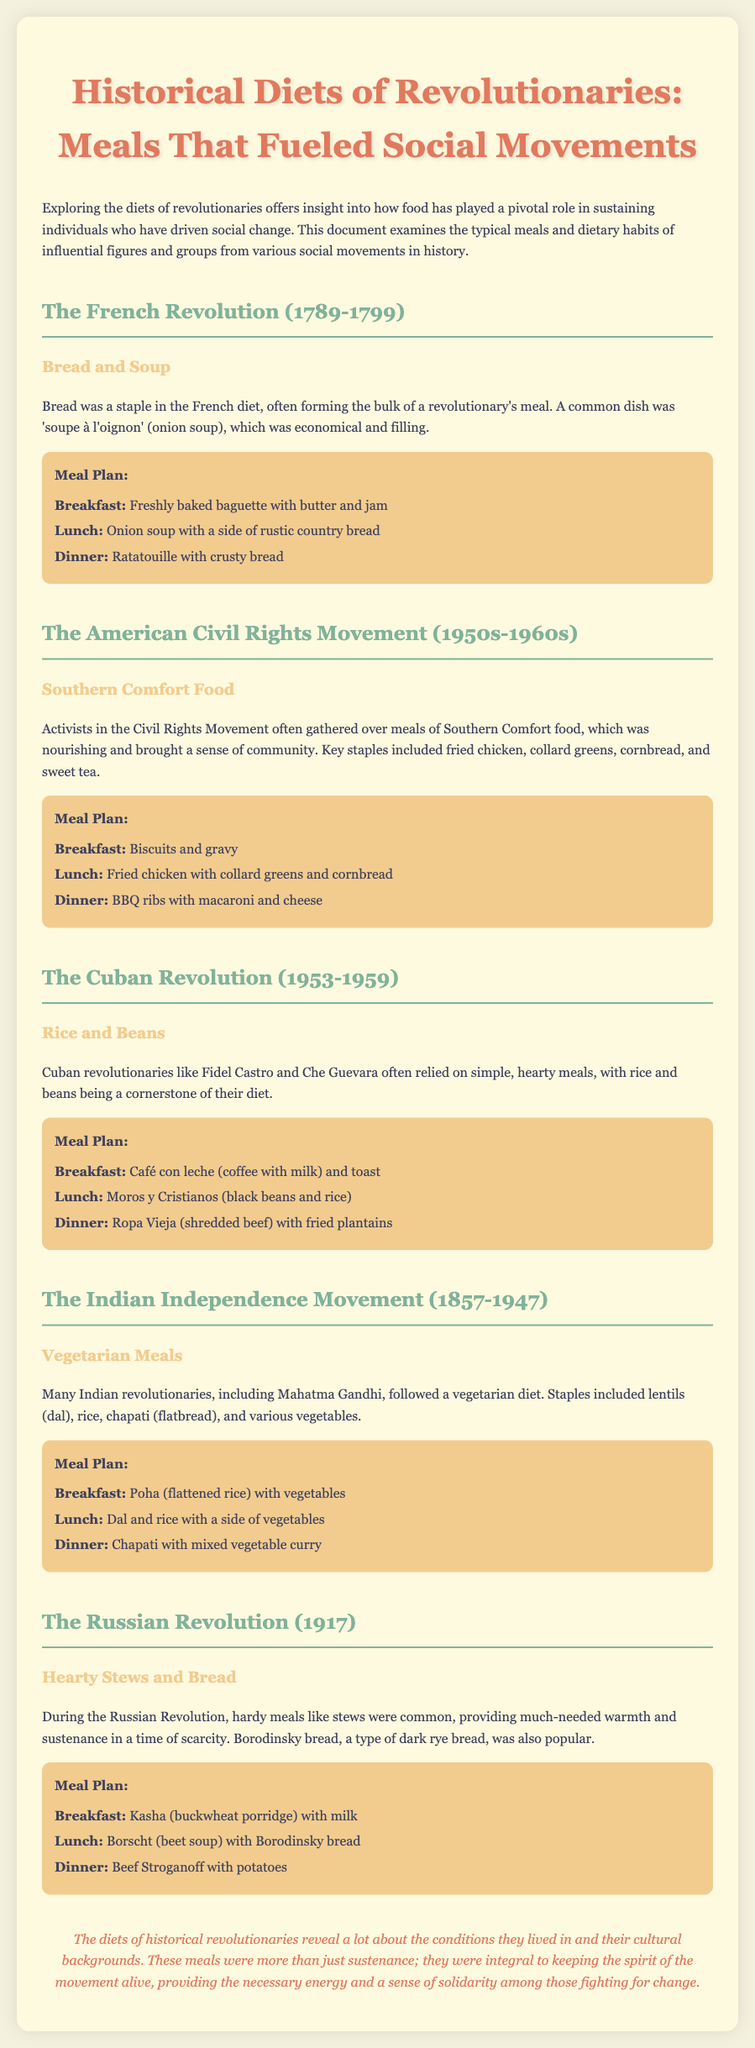what was a common dish during the French Revolution? The document states that 'soupe à l'oignon' (onion soup) was a common dish during the French Revolution, which was economical and filling.
Answer: soupe à l'oignon which significant figure is associated with the Indian Independence Movement? The document mentions Mahatma Gandhi as a key revolutionary figure during the Indian Independence Movement.
Answer: Mahatma Gandhi what type of bread was popular during the Russian Revolution? The document highlights Borodinsky bread as a popular type of dark rye bread during the Russian Revolution.
Answer: Borodinsky bread how many meals are suggested in each meal plan? Each meal plan contains three suggested meals: breakfast, lunch, and dinner.
Answer: three which meal is suggested for lunch in the Cuban Revolution meal plan? The document indicates that Moros y Cristianos (black beans and rice) is suggested for lunch in the Cuban Revolution meal plan.
Answer: Moros y Cristianos what is a staple food mentioned in the American Civil Rights Movement meal plan? The document mentions fried chicken as a key staple in the meal plan for the American Civil Rights Movement.
Answer: fried chicken which beverage is included in the breakfast of the Cuban Revolution meal plan? Café con leche (coffee with milk) is noted as the beverage included in breakfast for the Cuban Revolution meal plan.
Answer: Café con leche what is the primary dietary preference of Indian revolutionaries? The document states that many Indian revolutionaries followed a vegetarian diet.
Answer: vegetarian diet what type of food characterized the meals of the American Civil Rights Movement? The document describes the meals as Southern Comfort food, which was nourishing and fostered community.
Answer: Southern Comfort food 